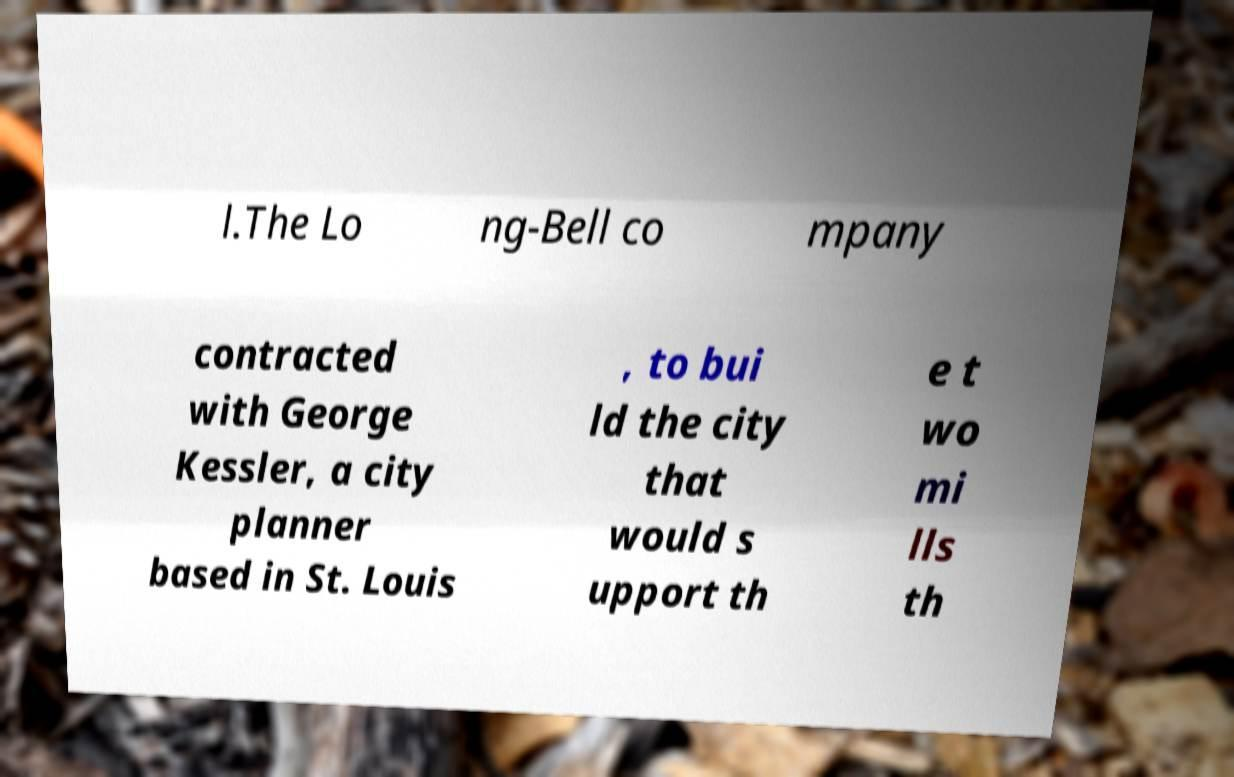Can you accurately transcribe the text from the provided image for me? l.The Lo ng-Bell co mpany contracted with George Kessler, a city planner based in St. Louis , to bui ld the city that would s upport th e t wo mi lls th 